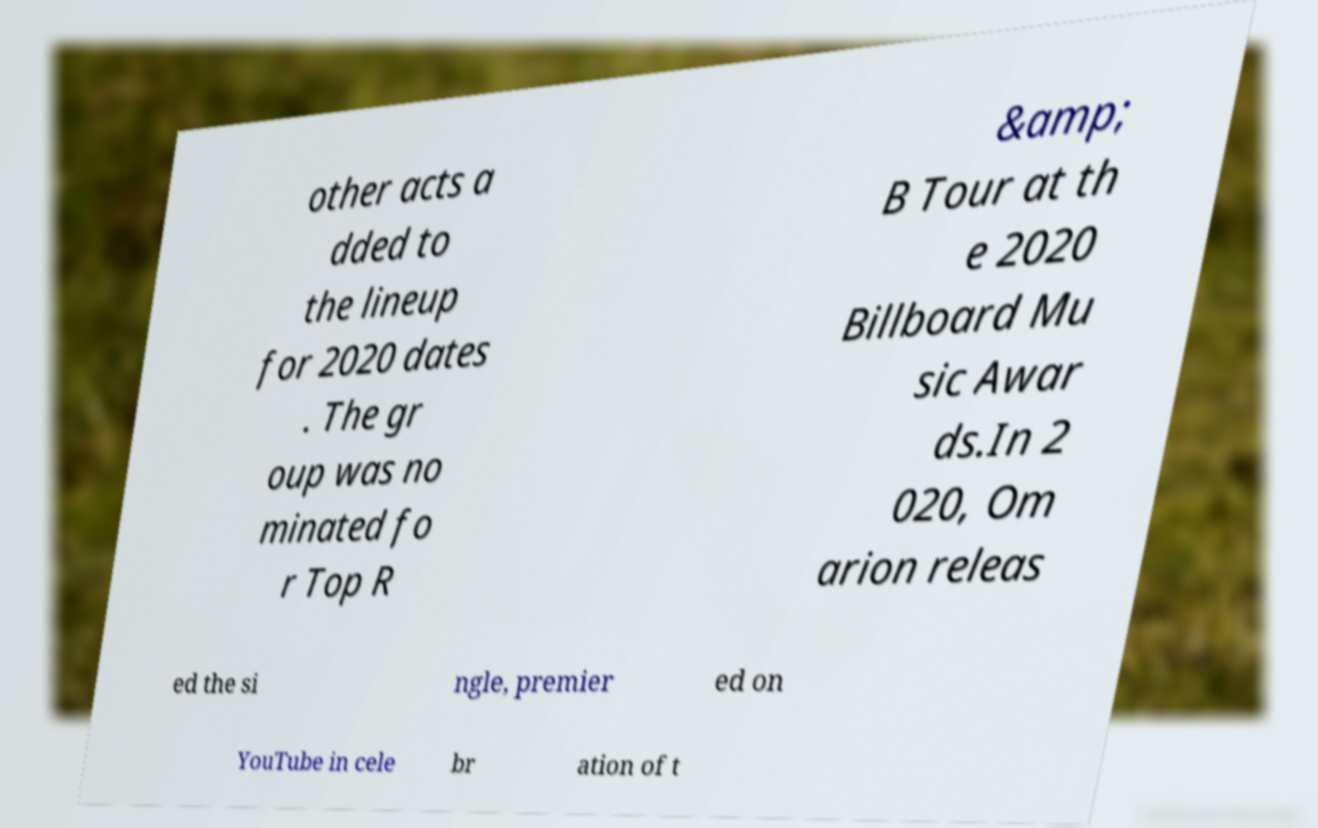For documentation purposes, I need the text within this image transcribed. Could you provide that? other acts a dded to the lineup for 2020 dates . The gr oup was no minated fo r Top R &amp; B Tour at th e 2020 Billboard Mu sic Awar ds.In 2 020, Om arion releas ed the si ngle, premier ed on YouTube in cele br ation of t 